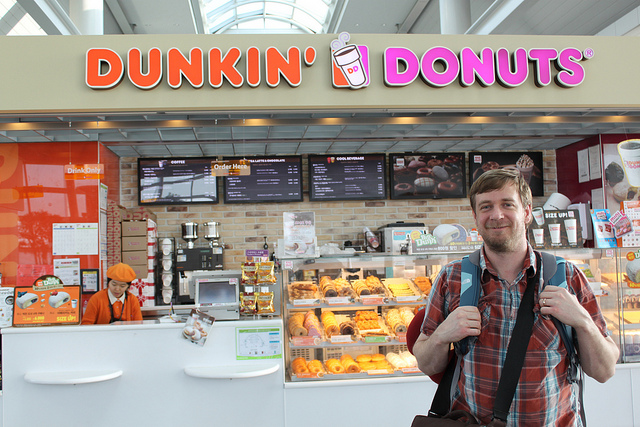Please extract the text content from this image. DUNKIN DONUTS 00 Hero 